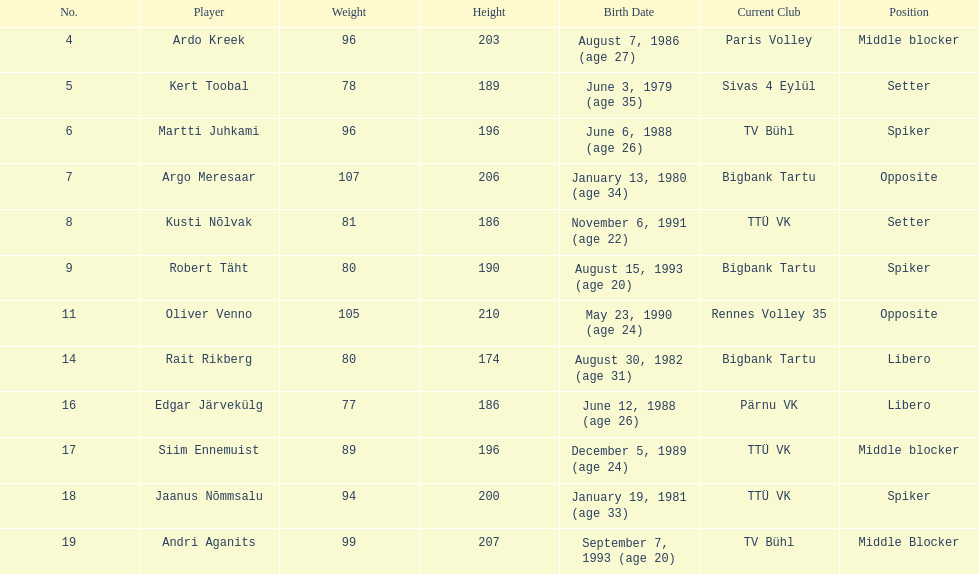Who is at least 25 years or older? Ardo Kreek, Kert Toobal, Martti Juhkami, Argo Meresaar, Rait Rikberg, Edgar Järvekülg, Jaanus Nõmmsalu. I'm looking to parse the entire table for insights. Could you assist me with that? {'header': ['No.', 'Player', 'Weight', 'Height', 'Birth Date', 'Current Club', 'Position'], 'rows': [['4', 'Ardo Kreek', '96', '203', 'August 7, 1986 (age\xa027)', 'Paris Volley', 'Middle blocker'], ['5', 'Kert Toobal', '78', '189', 'June 3, 1979 (age\xa035)', 'Sivas 4 Eylül', 'Setter'], ['6', 'Martti Juhkami', '96', '196', 'June 6, 1988 (age\xa026)', 'TV Bühl', 'Spiker'], ['7', 'Argo Meresaar', '107', '206', 'January 13, 1980 (age\xa034)', 'Bigbank Tartu', 'Opposite'], ['8', 'Kusti Nõlvak', '81', '186', 'November 6, 1991 (age\xa022)', 'TTÜ VK', 'Setter'], ['9', 'Robert Täht', '80', '190', 'August 15, 1993 (age\xa020)', 'Bigbank Tartu', 'Spiker'], ['11', 'Oliver Venno', '105', '210', 'May 23, 1990 (age\xa024)', 'Rennes Volley 35', 'Opposite'], ['14', 'Rait Rikberg', '80', '174', 'August 30, 1982 (age\xa031)', 'Bigbank Tartu', 'Libero'], ['16', 'Edgar Järvekülg', '77', '186', 'June 12, 1988 (age\xa026)', 'Pärnu VK', 'Libero'], ['17', 'Siim Ennemuist', '89', '196', 'December 5, 1989 (age\xa024)', 'TTÜ VK', 'Middle blocker'], ['18', 'Jaanus Nõmmsalu', '94', '200', 'January 19, 1981 (age\xa033)', 'TTÜ VK', 'Spiker'], ['19', 'Andri Aganits', '99', '207', 'September 7, 1993 (age\xa020)', 'TV Bühl', 'Middle Blocker']]} 